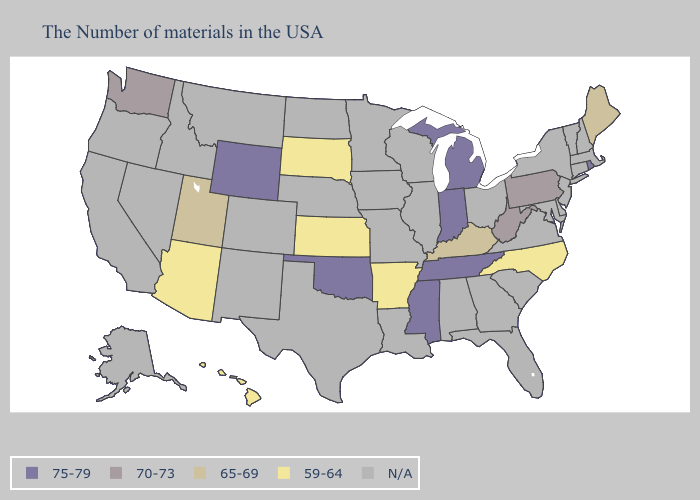What is the value of Tennessee?
Give a very brief answer. 75-79. Does Pennsylvania have the lowest value in the Northeast?
Short answer required. No. What is the value of Vermont?
Be succinct. N/A. What is the highest value in the USA?
Quick response, please. 75-79. Name the states that have a value in the range N/A?
Quick response, please. Massachusetts, New Hampshire, Vermont, Connecticut, New York, New Jersey, Delaware, Maryland, Virginia, South Carolina, Ohio, Florida, Georgia, Alabama, Wisconsin, Illinois, Louisiana, Missouri, Minnesota, Iowa, Nebraska, Texas, North Dakota, Colorado, New Mexico, Montana, Idaho, Nevada, California, Oregon, Alaska. What is the lowest value in the South?
Give a very brief answer. 59-64. Does Utah have the lowest value in the West?
Keep it brief. No. Which states have the lowest value in the USA?
Quick response, please. North Carolina, Arkansas, Kansas, South Dakota, Arizona, Hawaii. Name the states that have a value in the range 70-73?
Quick response, please. Pennsylvania, West Virginia, Washington. Among the states that border Illinois , does Kentucky have the highest value?
Answer briefly. No. What is the value of North Carolina?
Give a very brief answer. 59-64. What is the value of Illinois?
Be succinct. N/A. Name the states that have a value in the range N/A?
Keep it brief. Massachusetts, New Hampshire, Vermont, Connecticut, New York, New Jersey, Delaware, Maryland, Virginia, South Carolina, Ohio, Florida, Georgia, Alabama, Wisconsin, Illinois, Louisiana, Missouri, Minnesota, Iowa, Nebraska, Texas, North Dakota, Colorado, New Mexico, Montana, Idaho, Nevada, California, Oregon, Alaska. What is the value of Nebraska?
Answer briefly. N/A. 